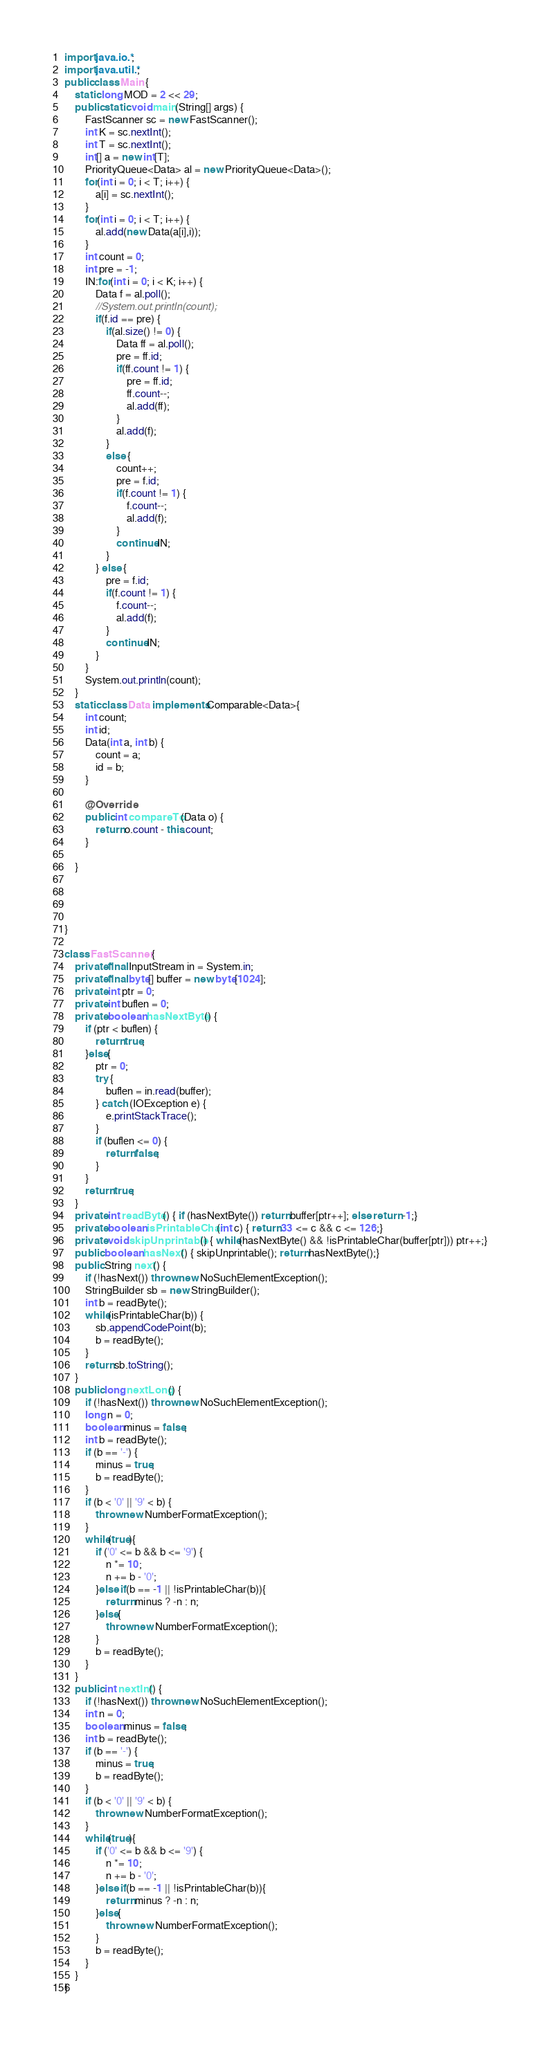Convert code to text. <code><loc_0><loc_0><loc_500><loc_500><_Java_>import java.io.*;
import java.util.*;
public class Main {
	static long MOD = 2 << 29;
	public static void main(String[] args) {
		FastScanner sc = new FastScanner();
		int K = sc.nextInt();
		int T = sc.nextInt();
		int[] a = new int[T];
		PriorityQueue<Data> al = new PriorityQueue<Data>();
		for(int i = 0; i < T; i++) {
			a[i] = sc.nextInt();
		}
		for(int i = 0; i < T; i++) {
			al.add(new Data(a[i],i));
		}
		int count = 0;
		int pre = -1;
		IN:for(int i = 0; i < K; i++) {
			Data f = al.poll();
			//System.out.println(count);
			if(f.id == pre) {
				if(al.size() != 0) {
					Data ff = al.poll();
					pre = ff.id;
					if(ff.count != 1) {
						pre = ff.id;
						ff.count--;
						al.add(ff);
					}
					al.add(f);
				}
				else {
					count++;
					pre = f.id;
					if(f.count != 1) {
						f.count--;
						al.add(f);
					}
					continue IN;
				}
			} else {
				pre = f.id;
				if(f.count != 1) {
					f.count--;
					al.add(f);
				}
				continue IN;
			}
		}
		System.out.println(count);
	}
	static class Data implements Comparable<Data>{
		int count;
		int id;
		Data(int a, int b) {
			count = a;
			id = b;
		}

		@Override
		public int compareTo(Data o) {
			return o.count - this.count;
		}
		
	}
	
	
	
	
}
 
class FastScanner {
    private final InputStream in = System.in;
    private final byte[] buffer = new byte[1024];
    private int ptr = 0;
    private int buflen = 0;
    private boolean hasNextByte() {
        if (ptr < buflen) {
            return true;
        }else{
            ptr = 0;
            try {
                buflen = in.read(buffer);
            } catch (IOException e) {
                e.printStackTrace();
            }
            if (buflen <= 0) {
                return false;
            }
        }
        return true;
    }
    private int readByte() { if (hasNextByte()) return buffer[ptr++]; else return -1;}
    private boolean isPrintableChar(int c) { return 33 <= c && c <= 126;}
    private void skipUnprintable() { while(hasNextByte() && !isPrintableChar(buffer[ptr])) ptr++;}
    public boolean hasNext() { skipUnprintable(); return hasNextByte();}
    public String next() {
        if (!hasNext()) throw new NoSuchElementException();
        StringBuilder sb = new StringBuilder();
        int b = readByte();
        while(isPrintableChar(b)) {
            sb.appendCodePoint(b);
            b = readByte();
        }
        return sb.toString();
    }
    public long nextLong() {
        if (!hasNext()) throw new NoSuchElementException();
        long n = 0;
        boolean minus = false;
        int b = readByte();
        if (b == '-') {
            minus = true;
            b = readByte();
        }
        if (b < '0' || '9' < b) {
            throw new NumberFormatException();
        }
        while(true){
            if ('0' <= b && b <= '9') {
                n *= 10;
                n += b - '0';
            }else if(b == -1 || !isPrintableChar(b)){
                return minus ? -n : n;
            }else{
                throw new NumberFormatException();
            }
            b = readByte();
        }
    }
    public int nextInt() {
        if (!hasNext()) throw new NoSuchElementException();
        int n = 0;
        boolean minus = false;
        int b = readByte();
        if (b == '-') {
            minus = true;
            b = readByte();
        }
        if (b < '0' || '9' < b) {
            throw new NumberFormatException();
        }
        while(true){
            if ('0' <= b && b <= '9') {
                n *= 10;
                n += b - '0';
            }else if(b == -1 || !isPrintableChar(b)){
                return minus ? -n : n;
            }else{
                throw new NumberFormatException();
            }
            b = readByte();
        }
    }
}</code> 